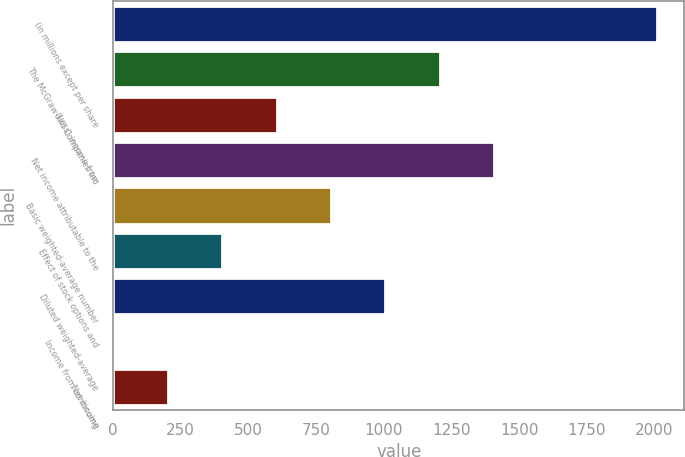Convert chart. <chart><loc_0><loc_0><loc_500><loc_500><bar_chart><fcel>(in millions except per share<fcel>The McGraw-Hill Companies Inc<fcel>(Loss) income from<fcel>Net income attributable to the<fcel>Basic weighted-average number<fcel>Effect of stock options and<fcel>Diluted weighted-average<fcel>Income from continuing<fcel>Net income<nl><fcel>2010<fcel>1206.74<fcel>604.31<fcel>1407.55<fcel>805.12<fcel>403.5<fcel>1005.93<fcel>1.88<fcel>202.69<nl></chart> 